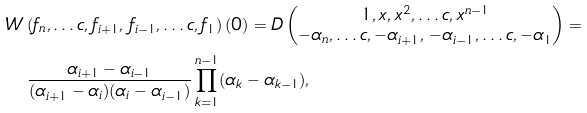<formula> <loc_0><loc_0><loc_500><loc_500>& W \left ( f _ { n } , \dots c , f _ { i + 1 } , \, f _ { i - 1 } , \dots c , f _ { 1 } \right ) ( 0 ) = D \begin{pmatrix} 1 , x , x ^ { 2 } , \dots c , x ^ { n - 1 } \\ - \alpha _ { n } , \dots c , - \alpha _ { i + 1 } , \, - \alpha _ { i - 1 } , \dots c , - \alpha _ { 1 } \end{pmatrix} = \\ & \quad \frac { \alpha _ { i + 1 } - \alpha _ { i - 1 } } { ( \alpha _ { i + 1 } - \alpha _ { i } ) ( \alpha _ { i } - \alpha _ { i - 1 } ) } \prod _ { k = 1 } ^ { n - 1 } ( \alpha _ { k } - \alpha _ { k - 1 } ) ,</formula> 